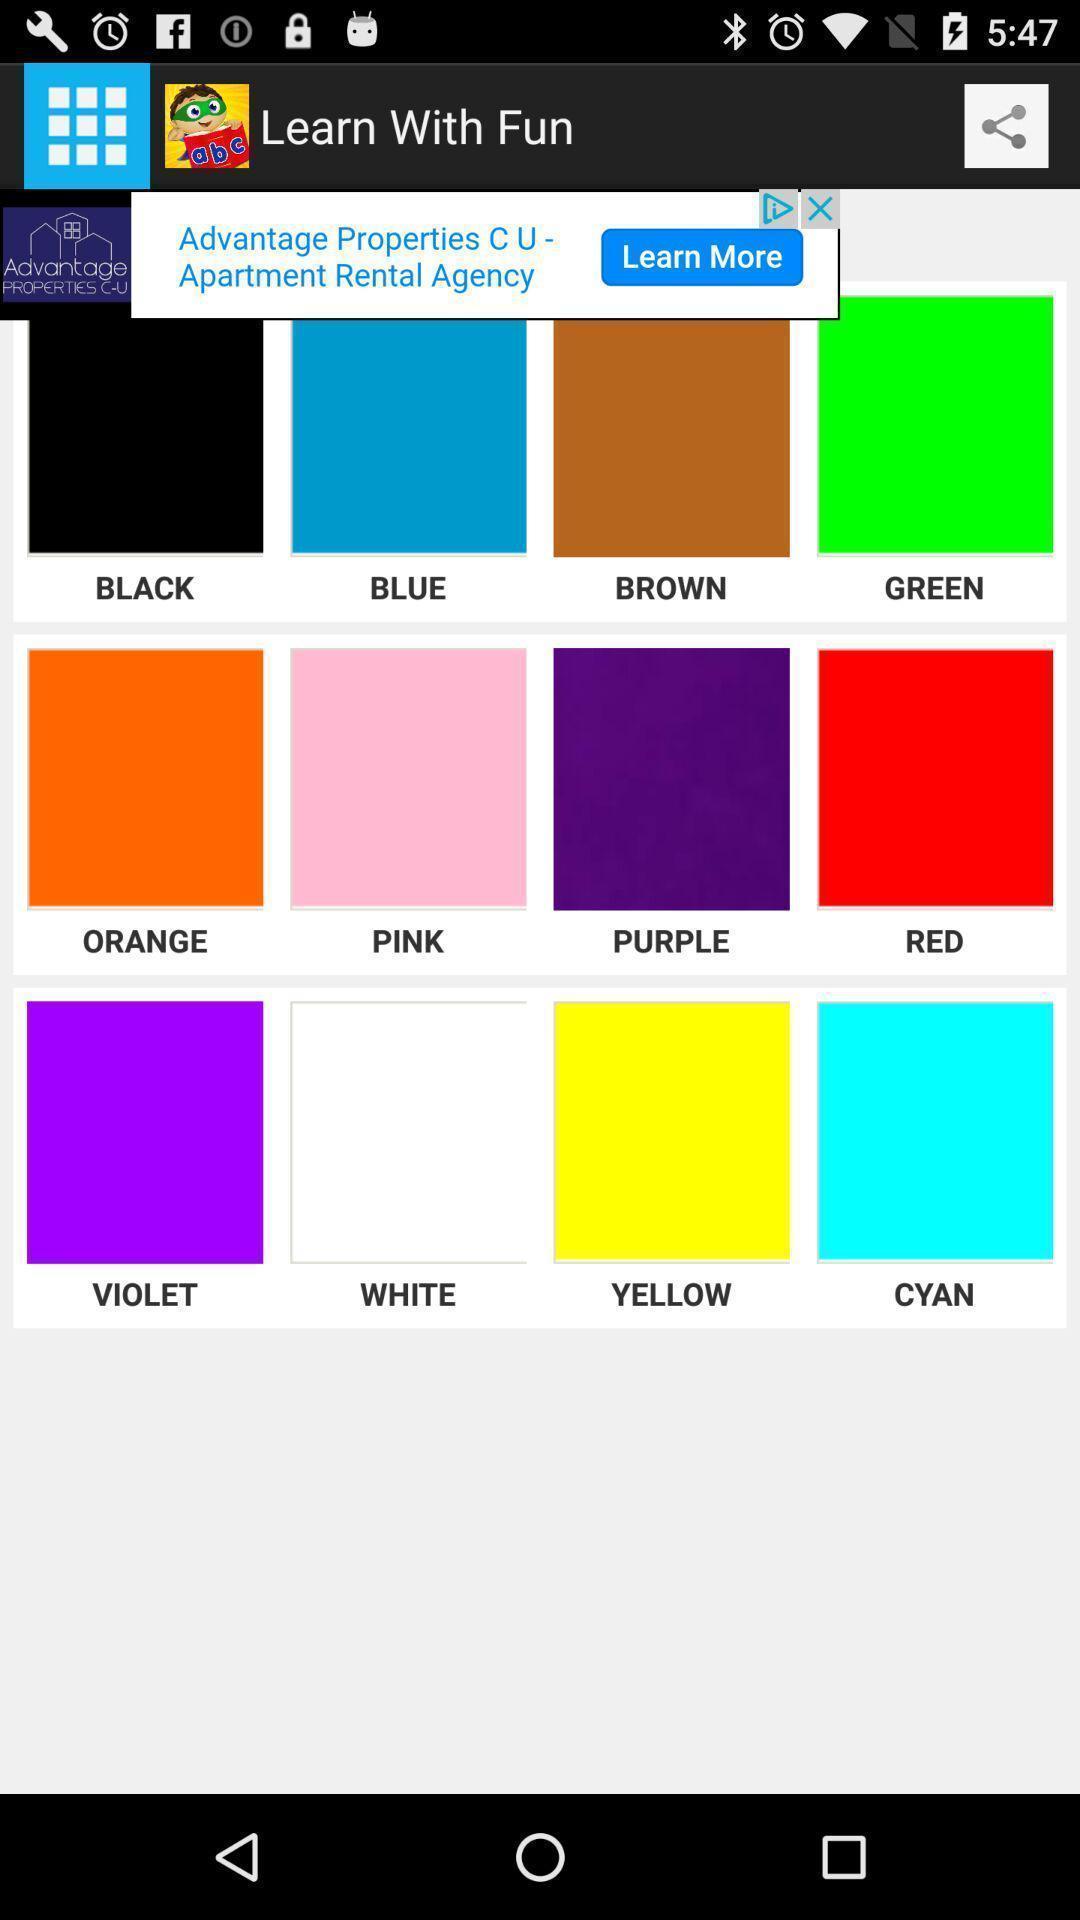What can you discern from this picture? Screen displaying the various colors with names. 